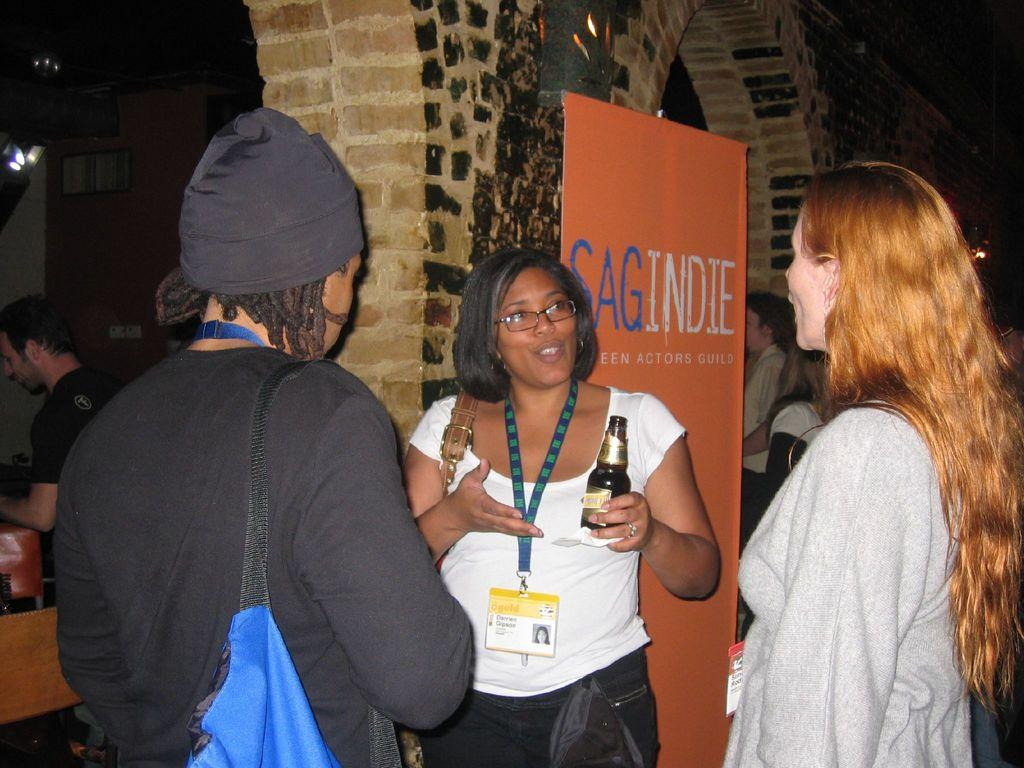What is happening in the middle of the image? There are people standing in the middle of the image. What is one person holding in the image? One person is holding a bottle. What can be seen behind the person holding the bottle? There is a banner behind the person holding the bottle. What is located behind the banner? There is a wall behind the banner. Can you describe the people behind the wall? There are people standing behind the wall. What type of horse can be seen grazing behind the wall in the image? There is no horse present in the image; it features people standing in the middle, a banner, and a wall. What color are the teeth of the person holding the bottle in the image? There is no indication of the person's teeth in the image, as their mouth is not visible. 